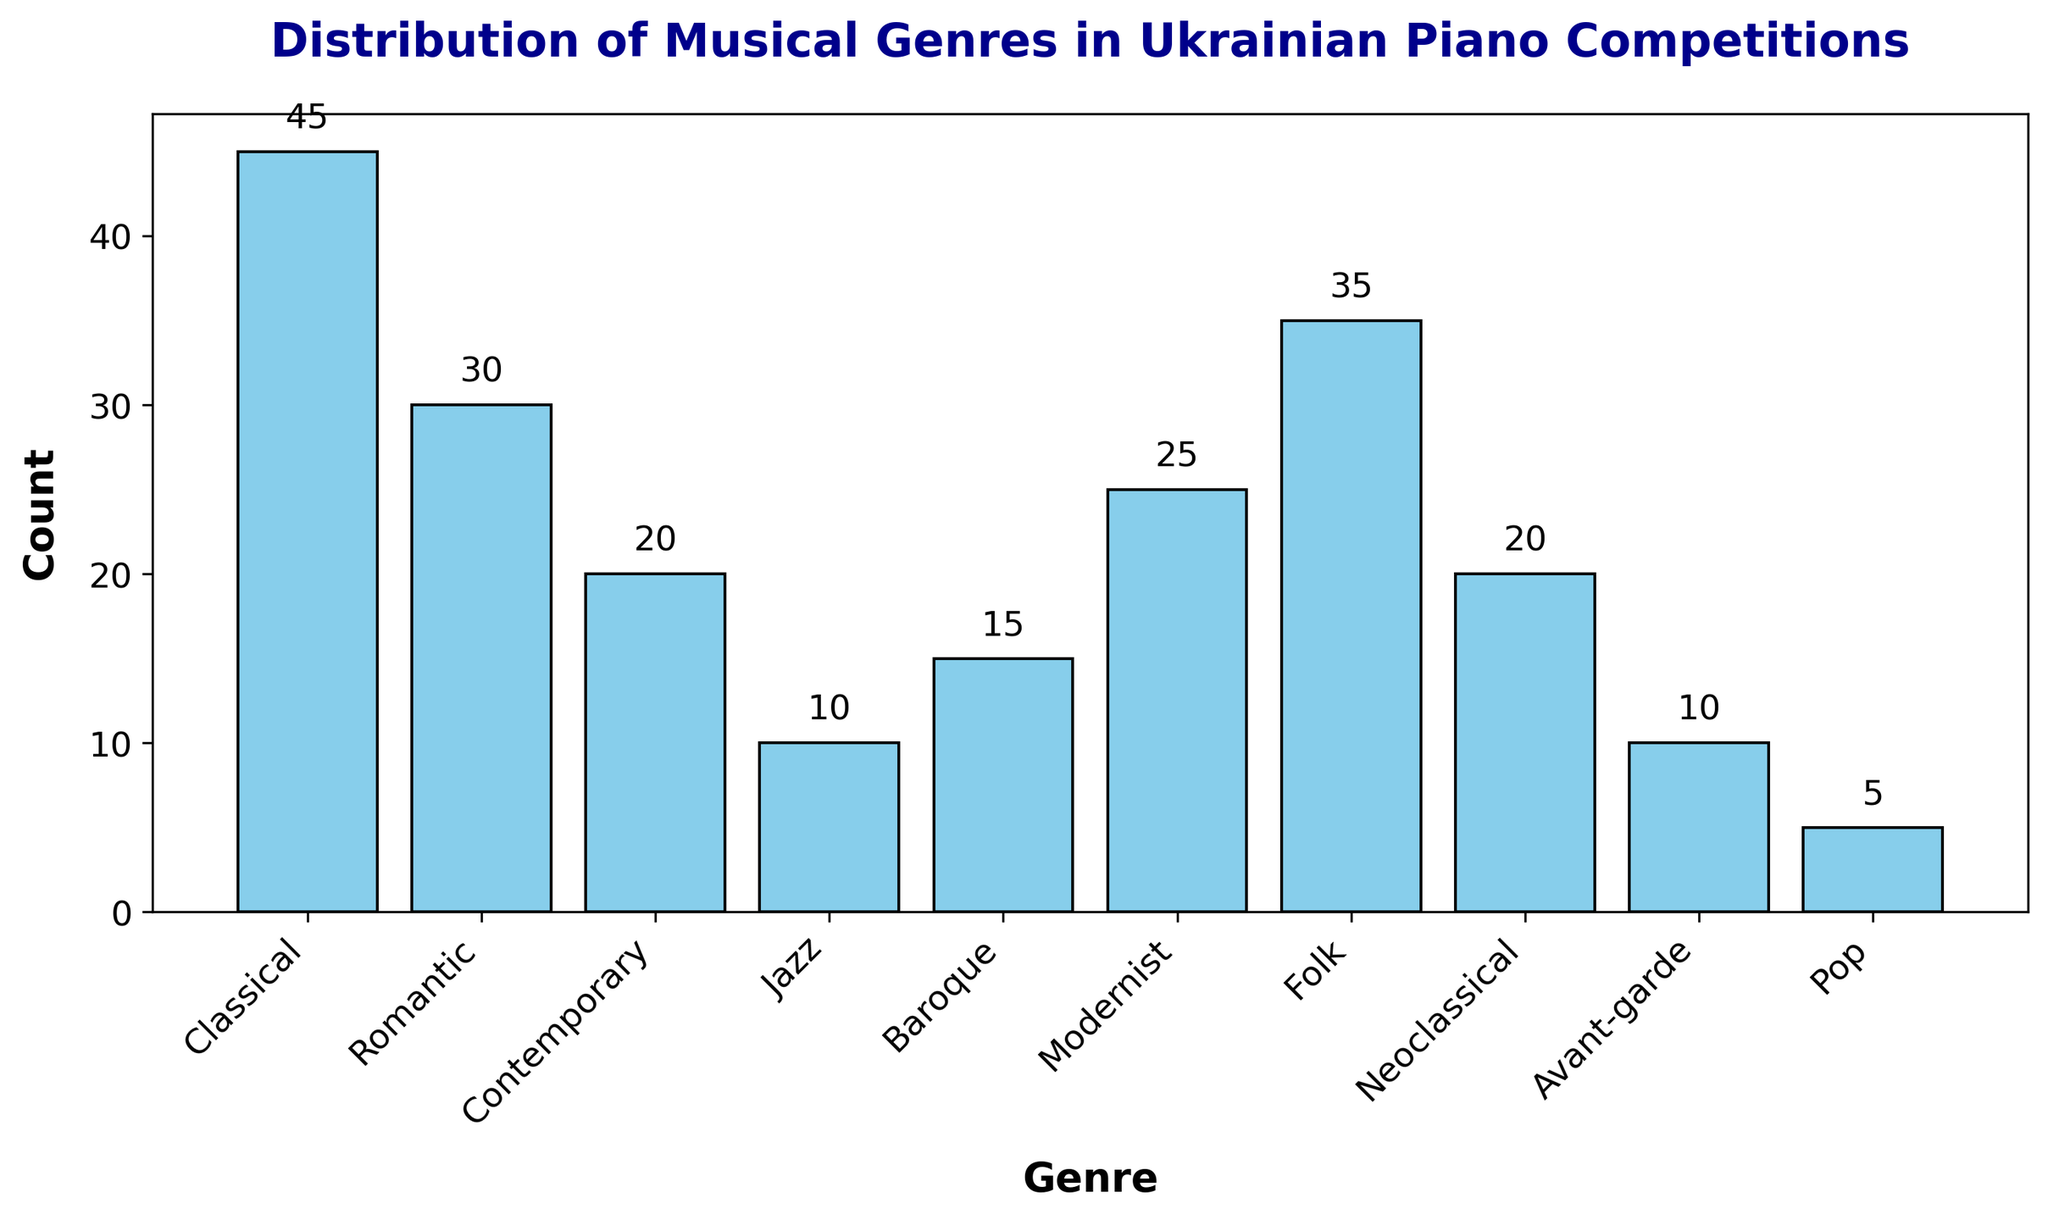What's the most frequently played genre in Ukrainian piano competitions? By looking at the figure, the genre with the highest bar represents the most frequently played genre. The bar for “Classical” is the tallest, indicating it has the highest count.
Answer: Classical Compare the counts between Classical and Romantic genres. What can you infer? By comparing the heights of the bars for Classical and Romantic, Classical has a height of 45, while Romantic has a height of 30. This indicates that Classical genres are played more often than Romantic genres in competitions.
Answer: Classical is played more often What is the total number of times Contemporary, Jazz, and Baroque genres were played? We need to sum the counts of Contemporary (20), Jazz (10), and Baroque (15). 20 + 10 + 15 = 45
Answer: 45 Which genre has the lowest count and what is it? Observing the bar heights, the shortest bar belongs to "Pop" with a height of 5, indicating it's the least played genre.
Answer: Pop, 5 Is the Folk genre played more often than Modernist? Comparing the bar heights, Folk has a count of 35, while Modernist has a count of 25. So, Folk is played more often than Modernist.
Answer: Yes What is the average count of Classical, Folk, and Contemporary genres? Sum the counts of Classical (45), Folk (35), and Contemporary (20). The sum is 100. Divide by the number of genres (3). 100 / 3 ≈ 33.33
Answer: 33.33 What is the difference in counts between Baroque and Avant-garde genres? Subtract the count of Avant-garde (10) from Baroque (15). 15 - 10 = 5
Answer: 5 Is the count for Romantic genres closer to those of Modernist or Folk genres? Romantic has a count of 30. Modernist has 25, and Folk has 35. The difference between Romantic and Modernist is 5 (30-25), and the difference between Romantic and Folk is also 5 (35-30). Hence, the counts are equally close to both Modernist and Folk.
Answer: Equally close to Modernist and Folk How many more times is the Classical genre played than the Pop genre? Subtract the count of Pop (5) from Classical (45). 45 - 5 = 40
Answer: 40 